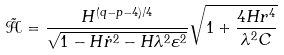<formula> <loc_0><loc_0><loc_500><loc_500>\tilde { \mathcal { H } } = \frac { H ^ { ( q - p - 4 ) / 4 } } { \sqrt { 1 - H \dot { r } ^ { 2 } - H \lambda ^ { 2 } \varepsilon ^ { 2 } } } \sqrt { 1 + \frac { 4 H r ^ { 4 } } { \lambda ^ { 2 } C } }</formula> 